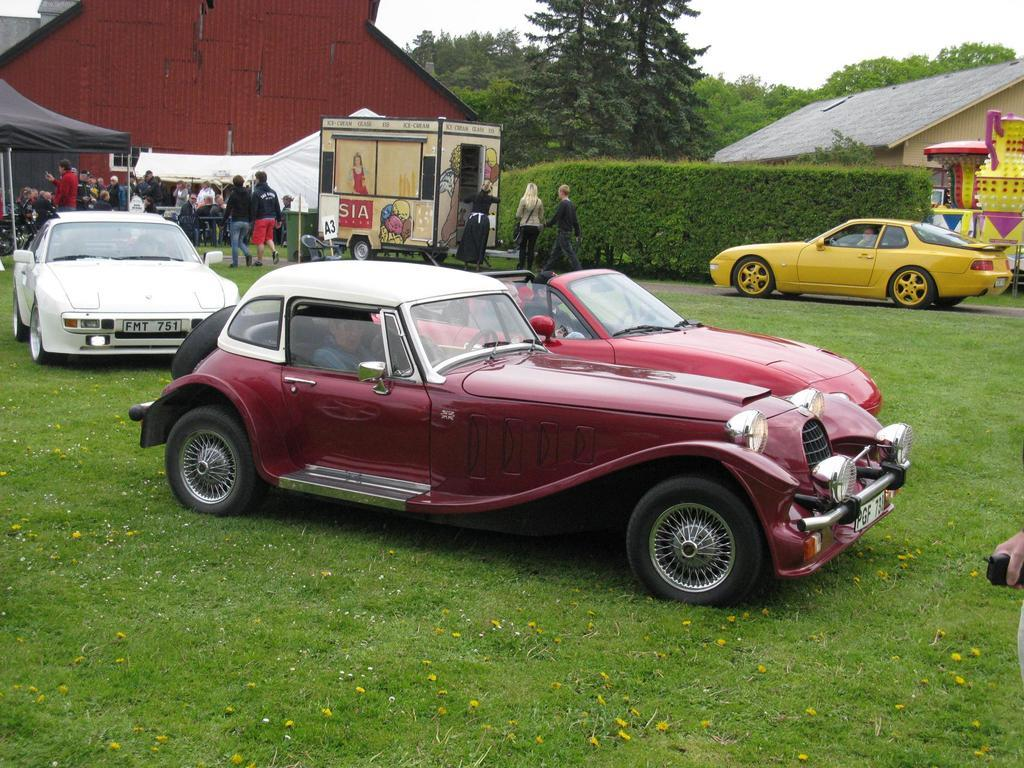What is the main subject of the image? The main subject of the image is cars in the center. What are the people in the cars doing? People are sitting in the cars. What can be seen in the background of the image? In the background of the image, there are people, tents, sheds, trees, and the sky. What type of ornament is hanging from the cars? There is no ornament hanging from the cars in the image. 